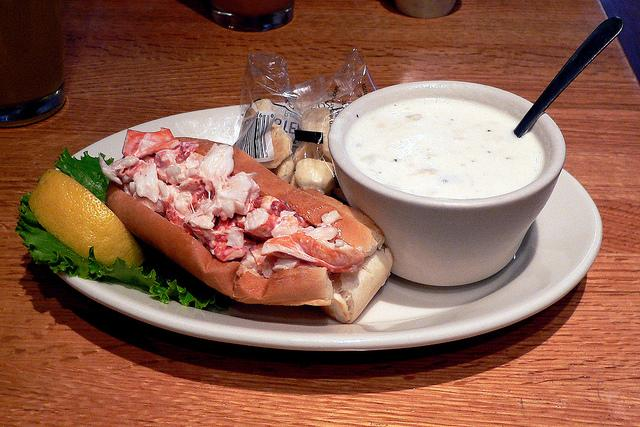What kind of citrus fruit is on top of the leaf on the right side of the white plate? lemon 